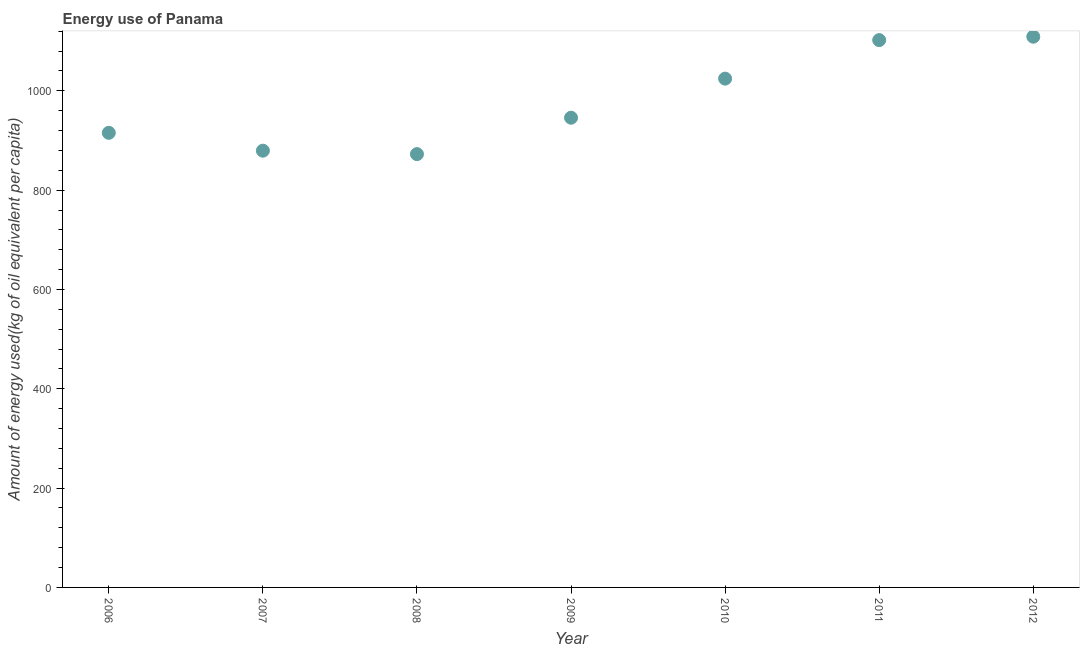What is the amount of energy used in 2012?
Offer a terse response. 1109.06. Across all years, what is the maximum amount of energy used?
Make the answer very short. 1109.06. Across all years, what is the minimum amount of energy used?
Your answer should be very brief. 872.59. In which year was the amount of energy used maximum?
Keep it short and to the point. 2012. In which year was the amount of energy used minimum?
Provide a succinct answer. 2008. What is the sum of the amount of energy used?
Provide a short and direct response. 6849.35. What is the difference between the amount of energy used in 2008 and 2010?
Your answer should be very brief. -152. What is the average amount of energy used per year?
Make the answer very short. 978.48. What is the median amount of energy used?
Your response must be concise. 945.89. Do a majority of the years between 2009 and 2007 (inclusive) have amount of energy used greater than 480 kg?
Give a very brief answer. No. What is the ratio of the amount of energy used in 2007 to that in 2008?
Provide a succinct answer. 1.01. Is the amount of energy used in 2009 less than that in 2011?
Provide a short and direct response. Yes. Is the difference between the amount of energy used in 2011 and 2012 greater than the difference between any two years?
Offer a very short reply. No. What is the difference between the highest and the second highest amount of energy used?
Offer a terse response. 6.86. Is the sum of the amount of energy used in 2009 and 2010 greater than the maximum amount of energy used across all years?
Provide a succinct answer. Yes. What is the difference between the highest and the lowest amount of energy used?
Keep it short and to the point. 236.46. In how many years, is the amount of energy used greater than the average amount of energy used taken over all years?
Offer a very short reply. 3. How many dotlines are there?
Your answer should be compact. 1. How many years are there in the graph?
Your answer should be compact. 7. What is the difference between two consecutive major ticks on the Y-axis?
Give a very brief answer. 200. Does the graph contain any zero values?
Offer a terse response. No. What is the title of the graph?
Your answer should be compact. Energy use of Panama. What is the label or title of the Y-axis?
Your answer should be compact. Amount of energy used(kg of oil equivalent per capita). What is the Amount of energy used(kg of oil equivalent per capita) in 2006?
Your answer should be very brief. 915.5. What is the Amount of energy used(kg of oil equivalent per capita) in 2007?
Your answer should be compact. 879.52. What is the Amount of energy used(kg of oil equivalent per capita) in 2008?
Your answer should be very brief. 872.59. What is the Amount of energy used(kg of oil equivalent per capita) in 2009?
Offer a terse response. 945.89. What is the Amount of energy used(kg of oil equivalent per capita) in 2010?
Ensure brevity in your answer.  1024.6. What is the Amount of energy used(kg of oil equivalent per capita) in 2011?
Give a very brief answer. 1102.19. What is the Amount of energy used(kg of oil equivalent per capita) in 2012?
Provide a succinct answer. 1109.06. What is the difference between the Amount of energy used(kg of oil equivalent per capita) in 2006 and 2007?
Your answer should be very brief. 35.97. What is the difference between the Amount of energy used(kg of oil equivalent per capita) in 2006 and 2008?
Give a very brief answer. 42.9. What is the difference between the Amount of energy used(kg of oil equivalent per capita) in 2006 and 2009?
Offer a very short reply. -30.4. What is the difference between the Amount of energy used(kg of oil equivalent per capita) in 2006 and 2010?
Provide a succinct answer. -109.1. What is the difference between the Amount of energy used(kg of oil equivalent per capita) in 2006 and 2011?
Your answer should be very brief. -186.7. What is the difference between the Amount of energy used(kg of oil equivalent per capita) in 2006 and 2012?
Offer a very short reply. -193.56. What is the difference between the Amount of energy used(kg of oil equivalent per capita) in 2007 and 2008?
Provide a short and direct response. 6.93. What is the difference between the Amount of energy used(kg of oil equivalent per capita) in 2007 and 2009?
Make the answer very short. -66.37. What is the difference between the Amount of energy used(kg of oil equivalent per capita) in 2007 and 2010?
Offer a very short reply. -145.07. What is the difference between the Amount of energy used(kg of oil equivalent per capita) in 2007 and 2011?
Offer a terse response. -222.67. What is the difference between the Amount of energy used(kg of oil equivalent per capita) in 2007 and 2012?
Your response must be concise. -229.53. What is the difference between the Amount of energy used(kg of oil equivalent per capita) in 2008 and 2009?
Provide a short and direct response. -73.3. What is the difference between the Amount of energy used(kg of oil equivalent per capita) in 2008 and 2010?
Give a very brief answer. -152. What is the difference between the Amount of energy used(kg of oil equivalent per capita) in 2008 and 2011?
Offer a very short reply. -229.6. What is the difference between the Amount of energy used(kg of oil equivalent per capita) in 2008 and 2012?
Provide a short and direct response. -236.46. What is the difference between the Amount of energy used(kg of oil equivalent per capita) in 2009 and 2010?
Provide a short and direct response. -78.7. What is the difference between the Amount of energy used(kg of oil equivalent per capita) in 2009 and 2011?
Your answer should be compact. -156.3. What is the difference between the Amount of energy used(kg of oil equivalent per capita) in 2009 and 2012?
Ensure brevity in your answer.  -163.16. What is the difference between the Amount of energy used(kg of oil equivalent per capita) in 2010 and 2011?
Your answer should be very brief. -77.6. What is the difference between the Amount of energy used(kg of oil equivalent per capita) in 2010 and 2012?
Offer a terse response. -84.46. What is the difference between the Amount of energy used(kg of oil equivalent per capita) in 2011 and 2012?
Provide a succinct answer. -6.86. What is the ratio of the Amount of energy used(kg of oil equivalent per capita) in 2006 to that in 2007?
Your answer should be very brief. 1.04. What is the ratio of the Amount of energy used(kg of oil equivalent per capita) in 2006 to that in 2008?
Keep it short and to the point. 1.05. What is the ratio of the Amount of energy used(kg of oil equivalent per capita) in 2006 to that in 2010?
Give a very brief answer. 0.89. What is the ratio of the Amount of energy used(kg of oil equivalent per capita) in 2006 to that in 2011?
Give a very brief answer. 0.83. What is the ratio of the Amount of energy used(kg of oil equivalent per capita) in 2006 to that in 2012?
Provide a short and direct response. 0.82. What is the ratio of the Amount of energy used(kg of oil equivalent per capita) in 2007 to that in 2008?
Make the answer very short. 1.01. What is the ratio of the Amount of energy used(kg of oil equivalent per capita) in 2007 to that in 2009?
Make the answer very short. 0.93. What is the ratio of the Amount of energy used(kg of oil equivalent per capita) in 2007 to that in 2010?
Your answer should be compact. 0.86. What is the ratio of the Amount of energy used(kg of oil equivalent per capita) in 2007 to that in 2011?
Make the answer very short. 0.8. What is the ratio of the Amount of energy used(kg of oil equivalent per capita) in 2007 to that in 2012?
Your answer should be compact. 0.79. What is the ratio of the Amount of energy used(kg of oil equivalent per capita) in 2008 to that in 2009?
Provide a short and direct response. 0.92. What is the ratio of the Amount of energy used(kg of oil equivalent per capita) in 2008 to that in 2010?
Your response must be concise. 0.85. What is the ratio of the Amount of energy used(kg of oil equivalent per capita) in 2008 to that in 2011?
Offer a very short reply. 0.79. What is the ratio of the Amount of energy used(kg of oil equivalent per capita) in 2008 to that in 2012?
Offer a very short reply. 0.79. What is the ratio of the Amount of energy used(kg of oil equivalent per capita) in 2009 to that in 2010?
Your response must be concise. 0.92. What is the ratio of the Amount of energy used(kg of oil equivalent per capita) in 2009 to that in 2011?
Your answer should be very brief. 0.86. What is the ratio of the Amount of energy used(kg of oil equivalent per capita) in 2009 to that in 2012?
Your answer should be compact. 0.85. What is the ratio of the Amount of energy used(kg of oil equivalent per capita) in 2010 to that in 2011?
Offer a terse response. 0.93. What is the ratio of the Amount of energy used(kg of oil equivalent per capita) in 2010 to that in 2012?
Your answer should be very brief. 0.92. 